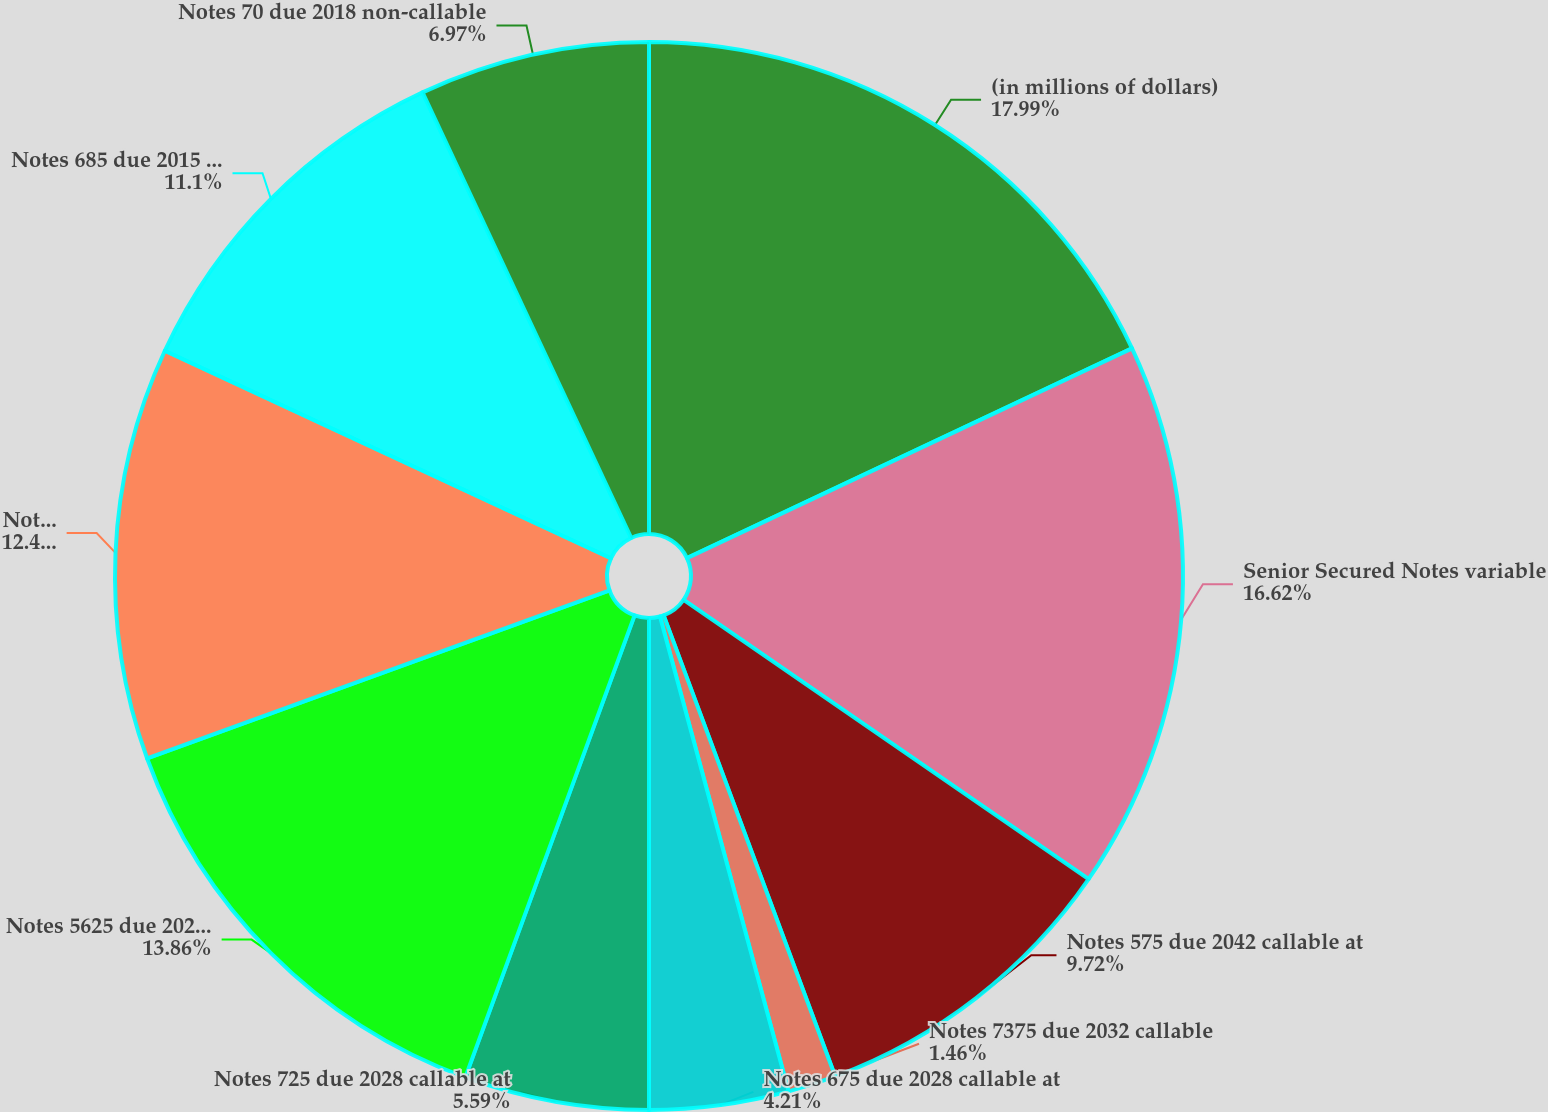Convert chart to OTSL. <chart><loc_0><loc_0><loc_500><loc_500><pie_chart><fcel>(in millions of dollars)<fcel>Senior Secured Notes variable<fcel>Notes 575 due 2042 callable at<fcel>Notes 7375 due 2032 callable<fcel>Notes 675 due 2028 callable at<fcel>Notes 725 due 2028 callable at<fcel>Notes 5625 due 2020 callable<fcel>Notes 7125 due 2016 callable<fcel>Notes 685 due 2015 callable at<fcel>Notes 70 due 2018 non-callable<nl><fcel>17.99%<fcel>16.62%<fcel>9.72%<fcel>1.46%<fcel>4.21%<fcel>5.59%<fcel>13.86%<fcel>12.48%<fcel>11.1%<fcel>6.97%<nl></chart> 